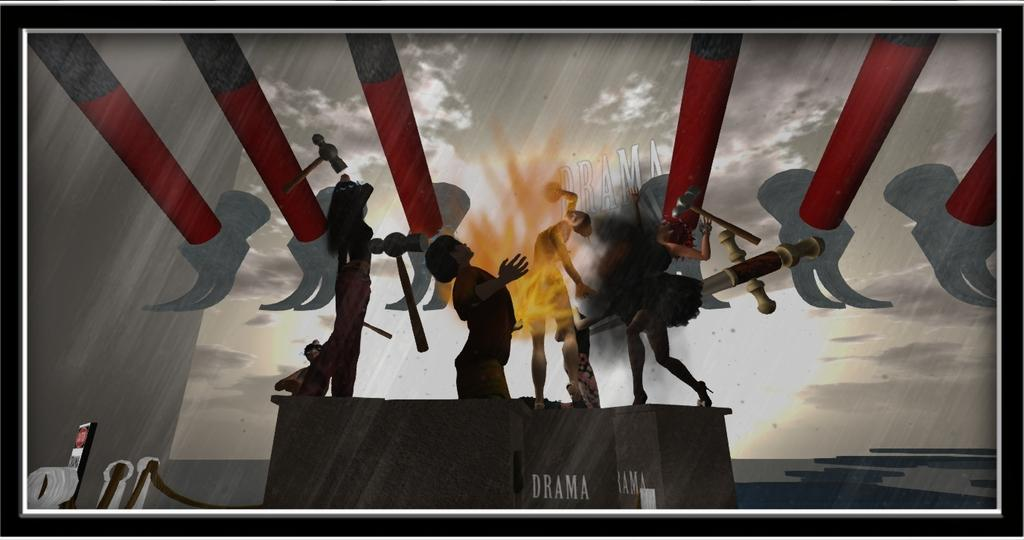How many persons are in the image? There are persons in the image. What object can be seen in the image that is typically used for striking? A hammer is visible in the image. What part of the natural environment is visible in the image? The sky is visible in the image. What type of objects are present in the image that are used for work or construction? There are tools in the image. What type of furniture is present in the image? There are tables in the image. What type of content is present in the image that conveys information or a message? Text is present in the image. What is the format of the image? The image is a photo frame. Can you tell me how many kitties are sitting on the tables in the image? There are no kitties present in the image; only persons, a hammer, the sky, tools, tables, text, and a photo frame are visible. What type of selection process is being depicted in the image? There is no selection process depicted in the image. 